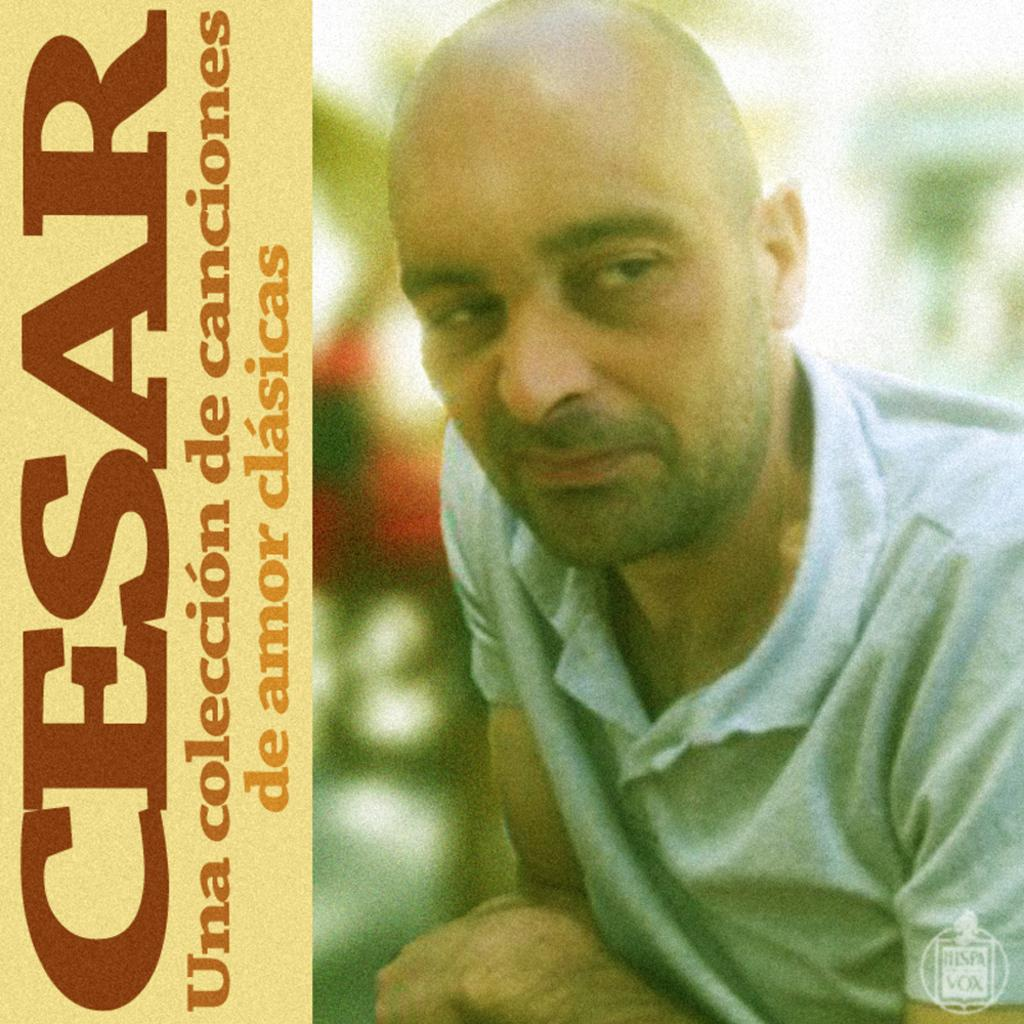Who is present in the image? There is a man in the image. What can be seen on the wall in the image? There is a poster in the image. What is written on the poster? The poster has the word "CESAR" written on it. What scent can be smelled from the poster in the image? There is no information about a scent associated with the poster in the image. 